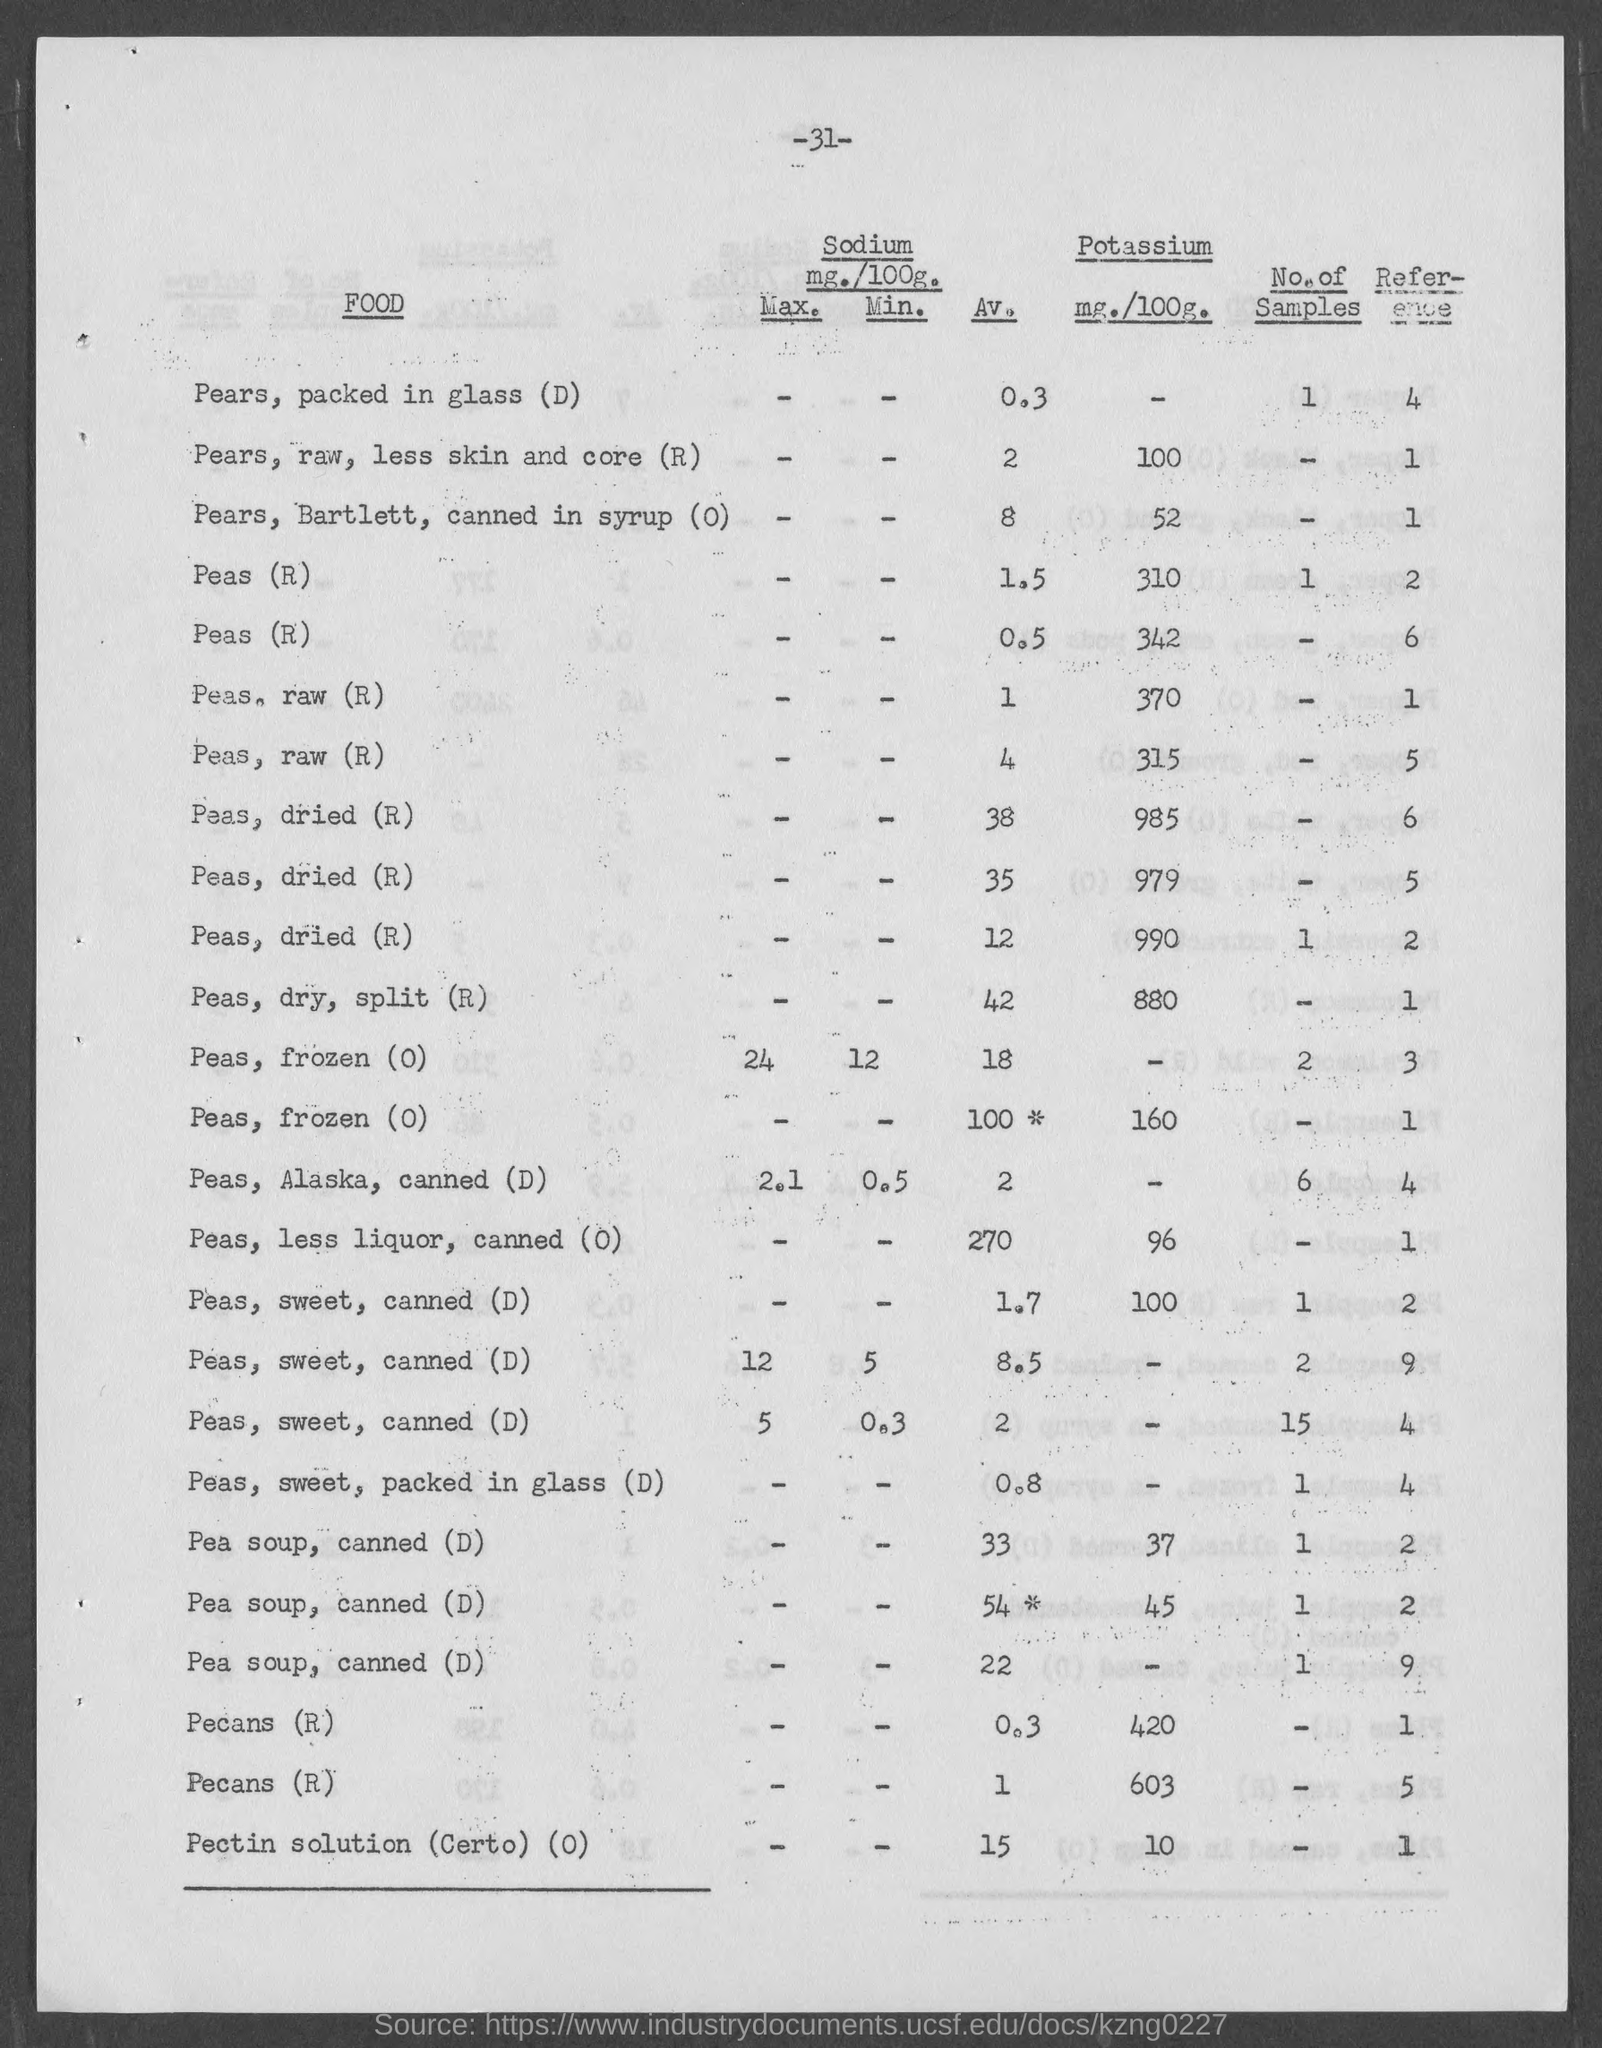What is the number at top of the page ?
Make the answer very short. 31. What is amount of potassium mg./100g. of pears,raw, less skin and core (r)?
Provide a succinct answer. 100. What is amount of potassium mg./100g. of pears, barlett, canned in syrup(o)?
Your response must be concise. 52. What is amount of potassium mg./100g. of peas, less liquor, canned (o)?
Provide a short and direct response. 96. What is amount of potassium mg./100g. of pectin solution (certo) (o)?
Offer a terse response. 10. 